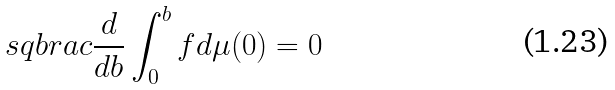<formula> <loc_0><loc_0><loc_500><loc_500>\ s q b r a c { \frac { d } { d b } \int _ { 0 } ^ { b } f d \mu } ( 0 ) = 0</formula> 